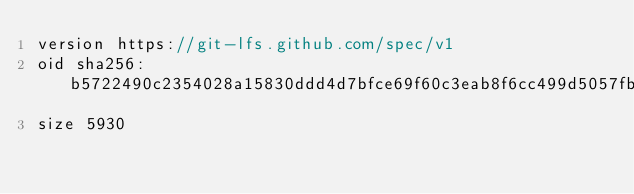<code> <loc_0><loc_0><loc_500><loc_500><_C++_>version https://git-lfs.github.com/spec/v1
oid sha256:b5722490c2354028a15830ddd4d7bfce69f60c3eab8f6cc499d5057fbea7e4b5
size 5930
</code> 